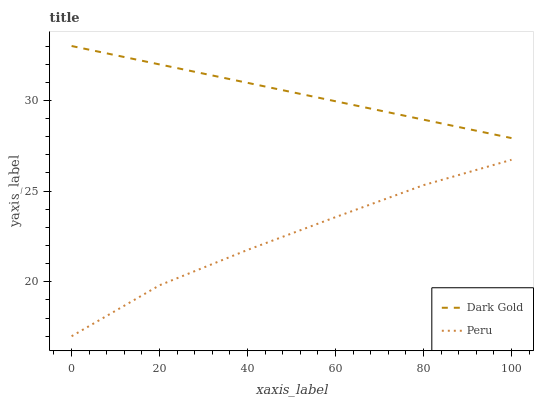Does Peru have the minimum area under the curve?
Answer yes or no. Yes. Does Dark Gold have the maximum area under the curve?
Answer yes or no. Yes. Does Dark Gold have the minimum area under the curve?
Answer yes or no. No. Is Dark Gold the smoothest?
Answer yes or no. Yes. Is Peru the roughest?
Answer yes or no. Yes. Is Dark Gold the roughest?
Answer yes or no. No. Does Peru have the lowest value?
Answer yes or no. Yes. Does Dark Gold have the lowest value?
Answer yes or no. No. Does Dark Gold have the highest value?
Answer yes or no. Yes. Is Peru less than Dark Gold?
Answer yes or no. Yes. Is Dark Gold greater than Peru?
Answer yes or no. Yes. Does Peru intersect Dark Gold?
Answer yes or no. No. 